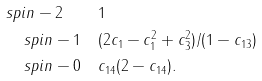Convert formula to latex. <formula><loc_0><loc_0><loc_500><loc_500>s p i n - 2 \quad & 1 \\ s p i n - 1 \quad & ( 2 c _ { 1 } - c _ { 1 } ^ { 2 } + c _ { 3 } ^ { 2 } ) / ( 1 - c _ { 1 3 } ) \\ s p i n - 0 \quad & c _ { 1 4 } ( 2 - c _ { 1 4 } ) .</formula> 